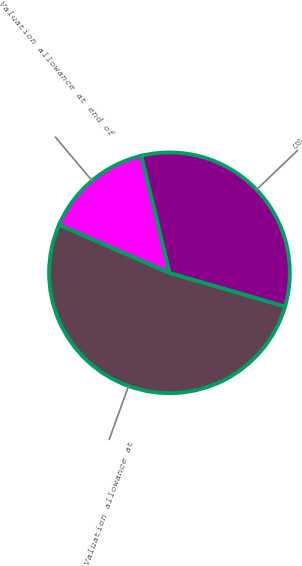Convert chart. <chart><loc_0><loc_0><loc_500><loc_500><pie_chart><fcel>Valuation allowance at<fcel>US<fcel>Valuation allowance at end of<nl><fcel>52.03%<fcel>33.28%<fcel>14.69%<nl></chart> 